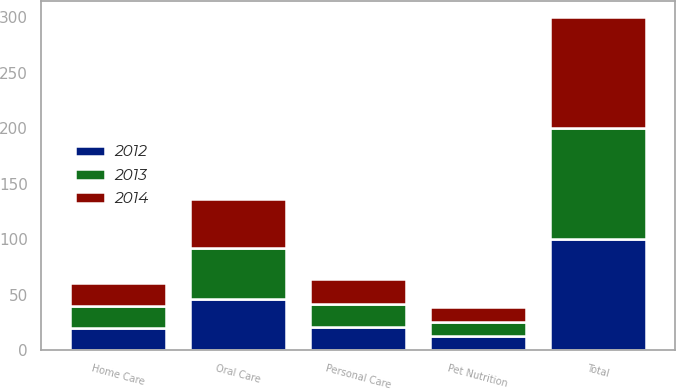<chart> <loc_0><loc_0><loc_500><loc_500><stacked_bar_chart><ecel><fcel>Oral Care<fcel>Personal Care<fcel>Home Care<fcel>Pet Nutrition<fcel>Total<nl><fcel>2012<fcel>46<fcel>21<fcel>20<fcel>13<fcel>100<nl><fcel>2013<fcel>46<fcel>21<fcel>20<fcel>13<fcel>100<nl><fcel>2014<fcel>44<fcel>22<fcel>21<fcel>13<fcel>100<nl></chart> 